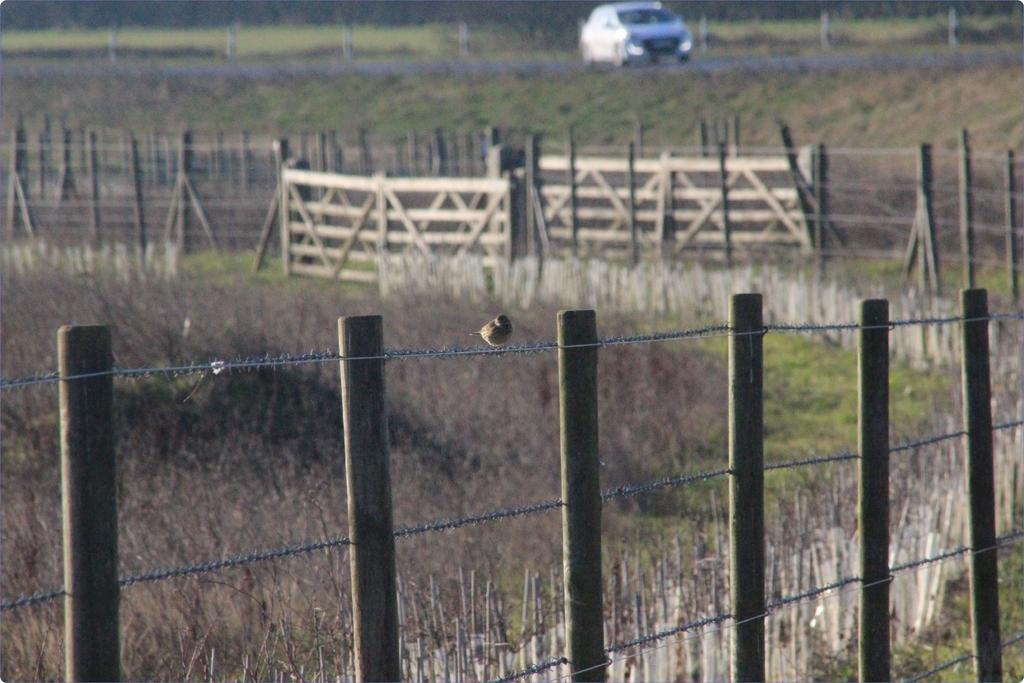What type of barrier can be seen in the image? There are fences in the image. What type of vegetation is at the bottom of the image? There is grass at the bottom of the image. What can be seen in the background of the image? There is a car visible in the background of the image. Where is the car located in relation to the road? The car is on a road. What type of discussion is taking place in the image? There is no discussion taking place in the image. What town is visible in the image? The image does not show a town; it only shows a car on a road and fences with grass. 